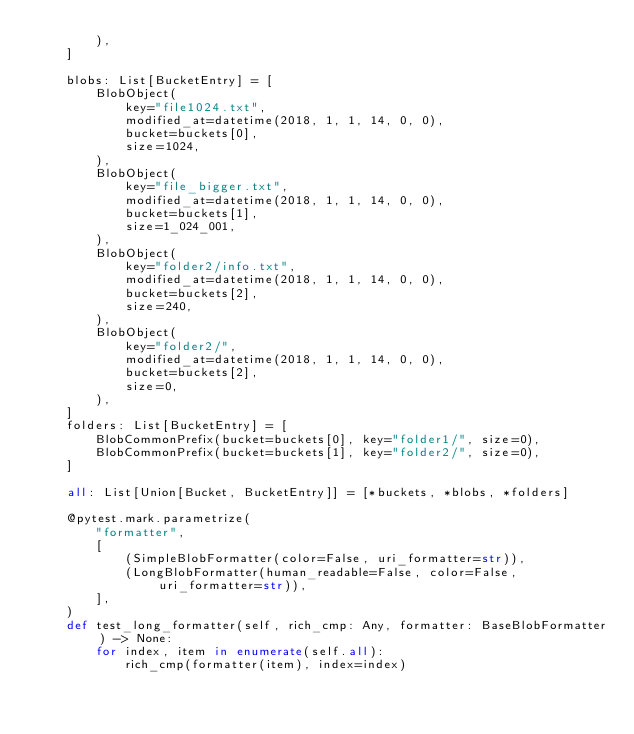<code> <loc_0><loc_0><loc_500><loc_500><_Python_>        ),
    ]

    blobs: List[BucketEntry] = [
        BlobObject(
            key="file1024.txt",
            modified_at=datetime(2018, 1, 1, 14, 0, 0),
            bucket=buckets[0],
            size=1024,
        ),
        BlobObject(
            key="file_bigger.txt",
            modified_at=datetime(2018, 1, 1, 14, 0, 0),
            bucket=buckets[1],
            size=1_024_001,
        ),
        BlobObject(
            key="folder2/info.txt",
            modified_at=datetime(2018, 1, 1, 14, 0, 0),
            bucket=buckets[2],
            size=240,
        ),
        BlobObject(
            key="folder2/",
            modified_at=datetime(2018, 1, 1, 14, 0, 0),
            bucket=buckets[2],
            size=0,
        ),
    ]
    folders: List[BucketEntry] = [
        BlobCommonPrefix(bucket=buckets[0], key="folder1/", size=0),
        BlobCommonPrefix(bucket=buckets[1], key="folder2/", size=0),
    ]

    all: List[Union[Bucket, BucketEntry]] = [*buckets, *blobs, *folders]

    @pytest.mark.parametrize(
        "formatter",
        [
            (SimpleBlobFormatter(color=False, uri_formatter=str)),
            (LongBlobFormatter(human_readable=False, color=False, uri_formatter=str)),
        ],
    )
    def test_long_formatter(self, rich_cmp: Any, formatter: BaseBlobFormatter) -> None:
        for index, item in enumerate(self.all):
            rich_cmp(formatter(item), index=index)
</code> 